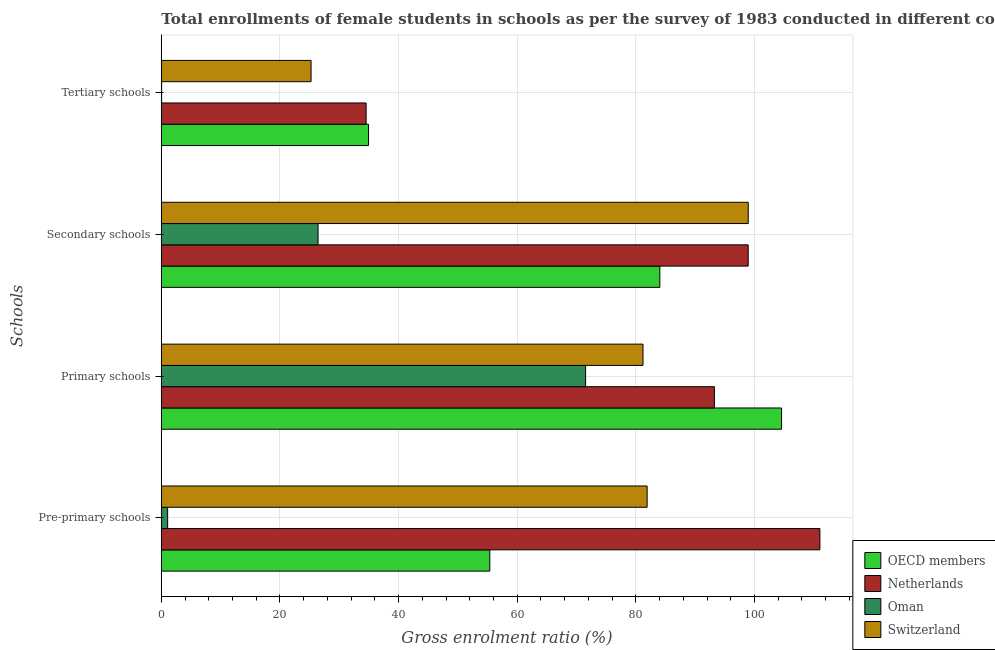How many groups of bars are there?
Your response must be concise. 4. Are the number of bars on each tick of the Y-axis equal?
Ensure brevity in your answer.  Yes. What is the label of the 1st group of bars from the top?
Make the answer very short. Tertiary schools. What is the gross enrolment ratio(female) in primary schools in Switzerland?
Keep it short and to the point. 81.21. Across all countries, what is the maximum gross enrolment ratio(female) in primary schools?
Provide a short and direct response. 104.57. Across all countries, what is the minimum gross enrolment ratio(female) in primary schools?
Provide a succinct answer. 71.53. In which country was the gross enrolment ratio(female) in tertiary schools minimum?
Your answer should be compact. Oman. What is the total gross enrolment ratio(female) in tertiary schools in the graph?
Give a very brief answer. 94.76. What is the difference between the gross enrolment ratio(female) in primary schools in OECD members and that in Oman?
Offer a terse response. 33.04. What is the difference between the gross enrolment ratio(female) in pre-primary schools in Oman and the gross enrolment ratio(female) in primary schools in OECD members?
Offer a very short reply. -103.5. What is the average gross enrolment ratio(female) in pre-primary schools per country?
Offer a very short reply. 62.35. What is the difference between the gross enrolment ratio(female) in tertiary schools and gross enrolment ratio(female) in secondary schools in Oman?
Your response must be concise. -26.38. In how many countries, is the gross enrolment ratio(female) in primary schools greater than 80 %?
Provide a short and direct response. 3. What is the ratio of the gross enrolment ratio(female) in secondary schools in Netherlands to that in Switzerland?
Your answer should be compact. 1. What is the difference between the highest and the second highest gross enrolment ratio(female) in pre-primary schools?
Provide a short and direct response. 29.13. What is the difference between the highest and the lowest gross enrolment ratio(female) in primary schools?
Provide a short and direct response. 33.04. In how many countries, is the gross enrolment ratio(female) in tertiary schools greater than the average gross enrolment ratio(female) in tertiary schools taken over all countries?
Offer a very short reply. 3. Is the sum of the gross enrolment ratio(female) in primary schools in OECD members and Switzerland greater than the maximum gross enrolment ratio(female) in pre-primary schools across all countries?
Offer a terse response. Yes. What does the 3rd bar from the top in Pre-primary schools represents?
Your response must be concise. Netherlands. How many countries are there in the graph?
Ensure brevity in your answer.  4. Does the graph contain grids?
Give a very brief answer. Yes. Where does the legend appear in the graph?
Give a very brief answer. Bottom right. How many legend labels are there?
Your answer should be very brief. 4. What is the title of the graph?
Give a very brief answer. Total enrollments of female students in schools as per the survey of 1983 conducted in different countries. What is the label or title of the X-axis?
Provide a short and direct response. Gross enrolment ratio (%). What is the label or title of the Y-axis?
Your response must be concise. Schools. What is the Gross enrolment ratio (%) in OECD members in Pre-primary schools?
Give a very brief answer. 55.38. What is the Gross enrolment ratio (%) in Netherlands in Pre-primary schools?
Make the answer very short. 111.03. What is the Gross enrolment ratio (%) in Oman in Pre-primary schools?
Keep it short and to the point. 1.07. What is the Gross enrolment ratio (%) in Switzerland in Pre-primary schools?
Offer a very short reply. 81.9. What is the Gross enrolment ratio (%) in OECD members in Primary schools?
Give a very brief answer. 104.57. What is the Gross enrolment ratio (%) in Netherlands in Primary schools?
Provide a succinct answer. 93.25. What is the Gross enrolment ratio (%) of Oman in Primary schools?
Ensure brevity in your answer.  71.53. What is the Gross enrolment ratio (%) of Switzerland in Primary schools?
Keep it short and to the point. 81.21. What is the Gross enrolment ratio (%) of OECD members in Secondary schools?
Your answer should be very brief. 84.05. What is the Gross enrolment ratio (%) of Netherlands in Secondary schools?
Offer a very short reply. 98.94. What is the Gross enrolment ratio (%) of Oman in Secondary schools?
Make the answer very short. 26.43. What is the Gross enrolment ratio (%) in Switzerland in Secondary schools?
Offer a very short reply. 98.95. What is the Gross enrolment ratio (%) of OECD members in Tertiary schools?
Ensure brevity in your answer.  34.94. What is the Gross enrolment ratio (%) in Netherlands in Tertiary schools?
Offer a very short reply. 34.53. What is the Gross enrolment ratio (%) of Oman in Tertiary schools?
Ensure brevity in your answer.  0.05. What is the Gross enrolment ratio (%) of Switzerland in Tertiary schools?
Keep it short and to the point. 25.25. Across all Schools, what is the maximum Gross enrolment ratio (%) of OECD members?
Keep it short and to the point. 104.57. Across all Schools, what is the maximum Gross enrolment ratio (%) in Netherlands?
Make the answer very short. 111.03. Across all Schools, what is the maximum Gross enrolment ratio (%) in Oman?
Your answer should be compact. 71.53. Across all Schools, what is the maximum Gross enrolment ratio (%) of Switzerland?
Provide a succinct answer. 98.95. Across all Schools, what is the minimum Gross enrolment ratio (%) in OECD members?
Give a very brief answer. 34.94. Across all Schools, what is the minimum Gross enrolment ratio (%) in Netherlands?
Make the answer very short. 34.53. Across all Schools, what is the minimum Gross enrolment ratio (%) of Oman?
Provide a succinct answer. 0.05. Across all Schools, what is the minimum Gross enrolment ratio (%) in Switzerland?
Give a very brief answer. 25.25. What is the total Gross enrolment ratio (%) of OECD members in the graph?
Provide a succinct answer. 278.93. What is the total Gross enrolment ratio (%) of Netherlands in the graph?
Make the answer very short. 337.75. What is the total Gross enrolment ratio (%) of Oman in the graph?
Offer a very short reply. 99.07. What is the total Gross enrolment ratio (%) of Switzerland in the graph?
Your answer should be compact. 287.32. What is the difference between the Gross enrolment ratio (%) of OECD members in Pre-primary schools and that in Primary schools?
Ensure brevity in your answer.  -49.19. What is the difference between the Gross enrolment ratio (%) of Netherlands in Pre-primary schools and that in Primary schools?
Make the answer very short. 17.79. What is the difference between the Gross enrolment ratio (%) in Oman in Pre-primary schools and that in Primary schools?
Offer a very short reply. -70.47. What is the difference between the Gross enrolment ratio (%) of Switzerland in Pre-primary schools and that in Primary schools?
Ensure brevity in your answer.  0.69. What is the difference between the Gross enrolment ratio (%) of OECD members in Pre-primary schools and that in Secondary schools?
Offer a very short reply. -28.66. What is the difference between the Gross enrolment ratio (%) of Netherlands in Pre-primary schools and that in Secondary schools?
Ensure brevity in your answer.  12.09. What is the difference between the Gross enrolment ratio (%) of Oman in Pre-primary schools and that in Secondary schools?
Provide a short and direct response. -25.36. What is the difference between the Gross enrolment ratio (%) in Switzerland in Pre-primary schools and that in Secondary schools?
Your response must be concise. -17.05. What is the difference between the Gross enrolment ratio (%) of OECD members in Pre-primary schools and that in Tertiary schools?
Offer a terse response. 20.45. What is the difference between the Gross enrolment ratio (%) in Netherlands in Pre-primary schools and that in Tertiary schools?
Give a very brief answer. 76.5. What is the difference between the Gross enrolment ratio (%) of Oman in Pre-primary schools and that in Tertiary schools?
Your response must be concise. 1.02. What is the difference between the Gross enrolment ratio (%) in Switzerland in Pre-primary schools and that in Tertiary schools?
Ensure brevity in your answer.  56.66. What is the difference between the Gross enrolment ratio (%) in OECD members in Primary schools and that in Secondary schools?
Keep it short and to the point. 20.52. What is the difference between the Gross enrolment ratio (%) in Netherlands in Primary schools and that in Secondary schools?
Your response must be concise. -5.7. What is the difference between the Gross enrolment ratio (%) of Oman in Primary schools and that in Secondary schools?
Offer a terse response. 45.1. What is the difference between the Gross enrolment ratio (%) of Switzerland in Primary schools and that in Secondary schools?
Ensure brevity in your answer.  -17.74. What is the difference between the Gross enrolment ratio (%) of OECD members in Primary schools and that in Tertiary schools?
Provide a succinct answer. 69.63. What is the difference between the Gross enrolment ratio (%) of Netherlands in Primary schools and that in Tertiary schools?
Offer a terse response. 58.72. What is the difference between the Gross enrolment ratio (%) of Oman in Primary schools and that in Tertiary schools?
Provide a succinct answer. 71.48. What is the difference between the Gross enrolment ratio (%) of Switzerland in Primary schools and that in Tertiary schools?
Keep it short and to the point. 55.97. What is the difference between the Gross enrolment ratio (%) in OECD members in Secondary schools and that in Tertiary schools?
Your response must be concise. 49.11. What is the difference between the Gross enrolment ratio (%) in Netherlands in Secondary schools and that in Tertiary schools?
Your answer should be very brief. 64.41. What is the difference between the Gross enrolment ratio (%) of Oman in Secondary schools and that in Tertiary schools?
Your response must be concise. 26.38. What is the difference between the Gross enrolment ratio (%) in Switzerland in Secondary schools and that in Tertiary schools?
Offer a terse response. 73.71. What is the difference between the Gross enrolment ratio (%) of OECD members in Pre-primary schools and the Gross enrolment ratio (%) of Netherlands in Primary schools?
Your response must be concise. -37.86. What is the difference between the Gross enrolment ratio (%) in OECD members in Pre-primary schools and the Gross enrolment ratio (%) in Oman in Primary schools?
Your answer should be compact. -16.15. What is the difference between the Gross enrolment ratio (%) in OECD members in Pre-primary schools and the Gross enrolment ratio (%) in Switzerland in Primary schools?
Your answer should be compact. -25.83. What is the difference between the Gross enrolment ratio (%) of Netherlands in Pre-primary schools and the Gross enrolment ratio (%) of Oman in Primary schools?
Your answer should be compact. 39.5. What is the difference between the Gross enrolment ratio (%) of Netherlands in Pre-primary schools and the Gross enrolment ratio (%) of Switzerland in Primary schools?
Ensure brevity in your answer.  29.82. What is the difference between the Gross enrolment ratio (%) in Oman in Pre-primary schools and the Gross enrolment ratio (%) in Switzerland in Primary schools?
Make the answer very short. -80.15. What is the difference between the Gross enrolment ratio (%) of OECD members in Pre-primary schools and the Gross enrolment ratio (%) of Netherlands in Secondary schools?
Your answer should be very brief. -43.56. What is the difference between the Gross enrolment ratio (%) of OECD members in Pre-primary schools and the Gross enrolment ratio (%) of Oman in Secondary schools?
Ensure brevity in your answer.  28.96. What is the difference between the Gross enrolment ratio (%) in OECD members in Pre-primary schools and the Gross enrolment ratio (%) in Switzerland in Secondary schools?
Keep it short and to the point. -43.57. What is the difference between the Gross enrolment ratio (%) of Netherlands in Pre-primary schools and the Gross enrolment ratio (%) of Oman in Secondary schools?
Keep it short and to the point. 84.61. What is the difference between the Gross enrolment ratio (%) of Netherlands in Pre-primary schools and the Gross enrolment ratio (%) of Switzerland in Secondary schools?
Offer a terse response. 12.08. What is the difference between the Gross enrolment ratio (%) of Oman in Pre-primary schools and the Gross enrolment ratio (%) of Switzerland in Secondary schools?
Your answer should be compact. -97.89. What is the difference between the Gross enrolment ratio (%) in OECD members in Pre-primary schools and the Gross enrolment ratio (%) in Netherlands in Tertiary schools?
Your response must be concise. 20.85. What is the difference between the Gross enrolment ratio (%) of OECD members in Pre-primary schools and the Gross enrolment ratio (%) of Oman in Tertiary schools?
Offer a terse response. 55.33. What is the difference between the Gross enrolment ratio (%) of OECD members in Pre-primary schools and the Gross enrolment ratio (%) of Switzerland in Tertiary schools?
Ensure brevity in your answer.  30.14. What is the difference between the Gross enrolment ratio (%) of Netherlands in Pre-primary schools and the Gross enrolment ratio (%) of Oman in Tertiary schools?
Your answer should be compact. 110.98. What is the difference between the Gross enrolment ratio (%) of Netherlands in Pre-primary schools and the Gross enrolment ratio (%) of Switzerland in Tertiary schools?
Your answer should be very brief. 85.79. What is the difference between the Gross enrolment ratio (%) in Oman in Pre-primary schools and the Gross enrolment ratio (%) in Switzerland in Tertiary schools?
Make the answer very short. -24.18. What is the difference between the Gross enrolment ratio (%) in OECD members in Primary schools and the Gross enrolment ratio (%) in Netherlands in Secondary schools?
Provide a succinct answer. 5.63. What is the difference between the Gross enrolment ratio (%) of OECD members in Primary schools and the Gross enrolment ratio (%) of Oman in Secondary schools?
Give a very brief answer. 78.14. What is the difference between the Gross enrolment ratio (%) in OECD members in Primary schools and the Gross enrolment ratio (%) in Switzerland in Secondary schools?
Keep it short and to the point. 5.62. What is the difference between the Gross enrolment ratio (%) in Netherlands in Primary schools and the Gross enrolment ratio (%) in Oman in Secondary schools?
Your answer should be compact. 66.82. What is the difference between the Gross enrolment ratio (%) in Netherlands in Primary schools and the Gross enrolment ratio (%) in Switzerland in Secondary schools?
Your answer should be very brief. -5.71. What is the difference between the Gross enrolment ratio (%) in Oman in Primary schools and the Gross enrolment ratio (%) in Switzerland in Secondary schools?
Make the answer very short. -27.42. What is the difference between the Gross enrolment ratio (%) in OECD members in Primary schools and the Gross enrolment ratio (%) in Netherlands in Tertiary schools?
Provide a short and direct response. 70.04. What is the difference between the Gross enrolment ratio (%) in OECD members in Primary schools and the Gross enrolment ratio (%) in Oman in Tertiary schools?
Make the answer very short. 104.52. What is the difference between the Gross enrolment ratio (%) in OECD members in Primary schools and the Gross enrolment ratio (%) in Switzerland in Tertiary schools?
Provide a short and direct response. 79.32. What is the difference between the Gross enrolment ratio (%) in Netherlands in Primary schools and the Gross enrolment ratio (%) in Oman in Tertiary schools?
Your response must be concise. 93.2. What is the difference between the Gross enrolment ratio (%) of Netherlands in Primary schools and the Gross enrolment ratio (%) of Switzerland in Tertiary schools?
Provide a succinct answer. 68. What is the difference between the Gross enrolment ratio (%) of Oman in Primary schools and the Gross enrolment ratio (%) of Switzerland in Tertiary schools?
Keep it short and to the point. 46.28. What is the difference between the Gross enrolment ratio (%) in OECD members in Secondary schools and the Gross enrolment ratio (%) in Netherlands in Tertiary schools?
Ensure brevity in your answer.  49.52. What is the difference between the Gross enrolment ratio (%) in OECD members in Secondary schools and the Gross enrolment ratio (%) in Oman in Tertiary schools?
Offer a very short reply. 84. What is the difference between the Gross enrolment ratio (%) in OECD members in Secondary schools and the Gross enrolment ratio (%) in Switzerland in Tertiary schools?
Offer a terse response. 58.8. What is the difference between the Gross enrolment ratio (%) in Netherlands in Secondary schools and the Gross enrolment ratio (%) in Oman in Tertiary schools?
Give a very brief answer. 98.89. What is the difference between the Gross enrolment ratio (%) of Netherlands in Secondary schools and the Gross enrolment ratio (%) of Switzerland in Tertiary schools?
Your answer should be very brief. 73.7. What is the difference between the Gross enrolment ratio (%) in Oman in Secondary schools and the Gross enrolment ratio (%) in Switzerland in Tertiary schools?
Provide a short and direct response. 1.18. What is the average Gross enrolment ratio (%) of OECD members per Schools?
Ensure brevity in your answer.  69.73. What is the average Gross enrolment ratio (%) in Netherlands per Schools?
Your answer should be compact. 84.44. What is the average Gross enrolment ratio (%) of Oman per Schools?
Provide a short and direct response. 24.77. What is the average Gross enrolment ratio (%) of Switzerland per Schools?
Keep it short and to the point. 71.83. What is the difference between the Gross enrolment ratio (%) in OECD members and Gross enrolment ratio (%) in Netherlands in Pre-primary schools?
Provide a succinct answer. -55.65. What is the difference between the Gross enrolment ratio (%) in OECD members and Gross enrolment ratio (%) in Oman in Pre-primary schools?
Provide a succinct answer. 54.32. What is the difference between the Gross enrolment ratio (%) in OECD members and Gross enrolment ratio (%) in Switzerland in Pre-primary schools?
Offer a very short reply. -26.52. What is the difference between the Gross enrolment ratio (%) of Netherlands and Gross enrolment ratio (%) of Oman in Pre-primary schools?
Provide a short and direct response. 109.97. What is the difference between the Gross enrolment ratio (%) of Netherlands and Gross enrolment ratio (%) of Switzerland in Pre-primary schools?
Keep it short and to the point. 29.13. What is the difference between the Gross enrolment ratio (%) of Oman and Gross enrolment ratio (%) of Switzerland in Pre-primary schools?
Give a very brief answer. -80.84. What is the difference between the Gross enrolment ratio (%) in OECD members and Gross enrolment ratio (%) in Netherlands in Primary schools?
Offer a very short reply. 11.32. What is the difference between the Gross enrolment ratio (%) in OECD members and Gross enrolment ratio (%) in Oman in Primary schools?
Your answer should be compact. 33.04. What is the difference between the Gross enrolment ratio (%) of OECD members and Gross enrolment ratio (%) of Switzerland in Primary schools?
Give a very brief answer. 23.36. What is the difference between the Gross enrolment ratio (%) in Netherlands and Gross enrolment ratio (%) in Oman in Primary schools?
Keep it short and to the point. 21.71. What is the difference between the Gross enrolment ratio (%) in Netherlands and Gross enrolment ratio (%) in Switzerland in Primary schools?
Your answer should be very brief. 12.03. What is the difference between the Gross enrolment ratio (%) in Oman and Gross enrolment ratio (%) in Switzerland in Primary schools?
Provide a succinct answer. -9.68. What is the difference between the Gross enrolment ratio (%) in OECD members and Gross enrolment ratio (%) in Netherlands in Secondary schools?
Keep it short and to the point. -14.9. What is the difference between the Gross enrolment ratio (%) in OECD members and Gross enrolment ratio (%) in Oman in Secondary schools?
Your answer should be very brief. 57.62. What is the difference between the Gross enrolment ratio (%) of OECD members and Gross enrolment ratio (%) of Switzerland in Secondary schools?
Make the answer very short. -14.91. What is the difference between the Gross enrolment ratio (%) in Netherlands and Gross enrolment ratio (%) in Oman in Secondary schools?
Ensure brevity in your answer.  72.52. What is the difference between the Gross enrolment ratio (%) in Netherlands and Gross enrolment ratio (%) in Switzerland in Secondary schools?
Give a very brief answer. -0.01. What is the difference between the Gross enrolment ratio (%) of Oman and Gross enrolment ratio (%) of Switzerland in Secondary schools?
Offer a very short reply. -72.52. What is the difference between the Gross enrolment ratio (%) of OECD members and Gross enrolment ratio (%) of Netherlands in Tertiary schools?
Give a very brief answer. 0.41. What is the difference between the Gross enrolment ratio (%) of OECD members and Gross enrolment ratio (%) of Oman in Tertiary schools?
Your answer should be very brief. 34.89. What is the difference between the Gross enrolment ratio (%) in OECD members and Gross enrolment ratio (%) in Switzerland in Tertiary schools?
Give a very brief answer. 9.69. What is the difference between the Gross enrolment ratio (%) in Netherlands and Gross enrolment ratio (%) in Oman in Tertiary schools?
Provide a short and direct response. 34.48. What is the difference between the Gross enrolment ratio (%) of Netherlands and Gross enrolment ratio (%) of Switzerland in Tertiary schools?
Keep it short and to the point. 9.28. What is the difference between the Gross enrolment ratio (%) in Oman and Gross enrolment ratio (%) in Switzerland in Tertiary schools?
Your response must be concise. -25.2. What is the ratio of the Gross enrolment ratio (%) in OECD members in Pre-primary schools to that in Primary schools?
Provide a short and direct response. 0.53. What is the ratio of the Gross enrolment ratio (%) of Netherlands in Pre-primary schools to that in Primary schools?
Provide a short and direct response. 1.19. What is the ratio of the Gross enrolment ratio (%) in Oman in Pre-primary schools to that in Primary schools?
Your answer should be compact. 0.01. What is the ratio of the Gross enrolment ratio (%) in Switzerland in Pre-primary schools to that in Primary schools?
Your response must be concise. 1.01. What is the ratio of the Gross enrolment ratio (%) in OECD members in Pre-primary schools to that in Secondary schools?
Provide a short and direct response. 0.66. What is the ratio of the Gross enrolment ratio (%) of Netherlands in Pre-primary schools to that in Secondary schools?
Offer a very short reply. 1.12. What is the ratio of the Gross enrolment ratio (%) of Oman in Pre-primary schools to that in Secondary schools?
Provide a short and direct response. 0.04. What is the ratio of the Gross enrolment ratio (%) of Switzerland in Pre-primary schools to that in Secondary schools?
Offer a terse response. 0.83. What is the ratio of the Gross enrolment ratio (%) of OECD members in Pre-primary schools to that in Tertiary schools?
Your answer should be very brief. 1.59. What is the ratio of the Gross enrolment ratio (%) of Netherlands in Pre-primary schools to that in Tertiary schools?
Offer a very short reply. 3.22. What is the ratio of the Gross enrolment ratio (%) in Oman in Pre-primary schools to that in Tertiary schools?
Provide a short and direct response. 21.92. What is the ratio of the Gross enrolment ratio (%) in Switzerland in Pre-primary schools to that in Tertiary schools?
Your answer should be very brief. 3.24. What is the ratio of the Gross enrolment ratio (%) of OECD members in Primary schools to that in Secondary schools?
Your answer should be compact. 1.24. What is the ratio of the Gross enrolment ratio (%) of Netherlands in Primary schools to that in Secondary schools?
Keep it short and to the point. 0.94. What is the ratio of the Gross enrolment ratio (%) in Oman in Primary schools to that in Secondary schools?
Make the answer very short. 2.71. What is the ratio of the Gross enrolment ratio (%) of Switzerland in Primary schools to that in Secondary schools?
Give a very brief answer. 0.82. What is the ratio of the Gross enrolment ratio (%) of OECD members in Primary schools to that in Tertiary schools?
Ensure brevity in your answer.  2.99. What is the ratio of the Gross enrolment ratio (%) in Netherlands in Primary schools to that in Tertiary schools?
Your response must be concise. 2.7. What is the ratio of the Gross enrolment ratio (%) of Oman in Primary schools to that in Tertiary schools?
Ensure brevity in your answer.  1470.33. What is the ratio of the Gross enrolment ratio (%) of Switzerland in Primary schools to that in Tertiary schools?
Make the answer very short. 3.22. What is the ratio of the Gross enrolment ratio (%) of OECD members in Secondary schools to that in Tertiary schools?
Offer a terse response. 2.41. What is the ratio of the Gross enrolment ratio (%) in Netherlands in Secondary schools to that in Tertiary schools?
Ensure brevity in your answer.  2.87. What is the ratio of the Gross enrolment ratio (%) of Oman in Secondary schools to that in Tertiary schools?
Offer a very short reply. 543.22. What is the ratio of the Gross enrolment ratio (%) in Switzerland in Secondary schools to that in Tertiary schools?
Your answer should be very brief. 3.92. What is the difference between the highest and the second highest Gross enrolment ratio (%) in OECD members?
Offer a terse response. 20.52. What is the difference between the highest and the second highest Gross enrolment ratio (%) of Netherlands?
Keep it short and to the point. 12.09. What is the difference between the highest and the second highest Gross enrolment ratio (%) in Oman?
Ensure brevity in your answer.  45.1. What is the difference between the highest and the second highest Gross enrolment ratio (%) in Switzerland?
Provide a succinct answer. 17.05. What is the difference between the highest and the lowest Gross enrolment ratio (%) of OECD members?
Offer a very short reply. 69.63. What is the difference between the highest and the lowest Gross enrolment ratio (%) of Netherlands?
Keep it short and to the point. 76.5. What is the difference between the highest and the lowest Gross enrolment ratio (%) in Oman?
Your answer should be very brief. 71.48. What is the difference between the highest and the lowest Gross enrolment ratio (%) of Switzerland?
Offer a terse response. 73.71. 